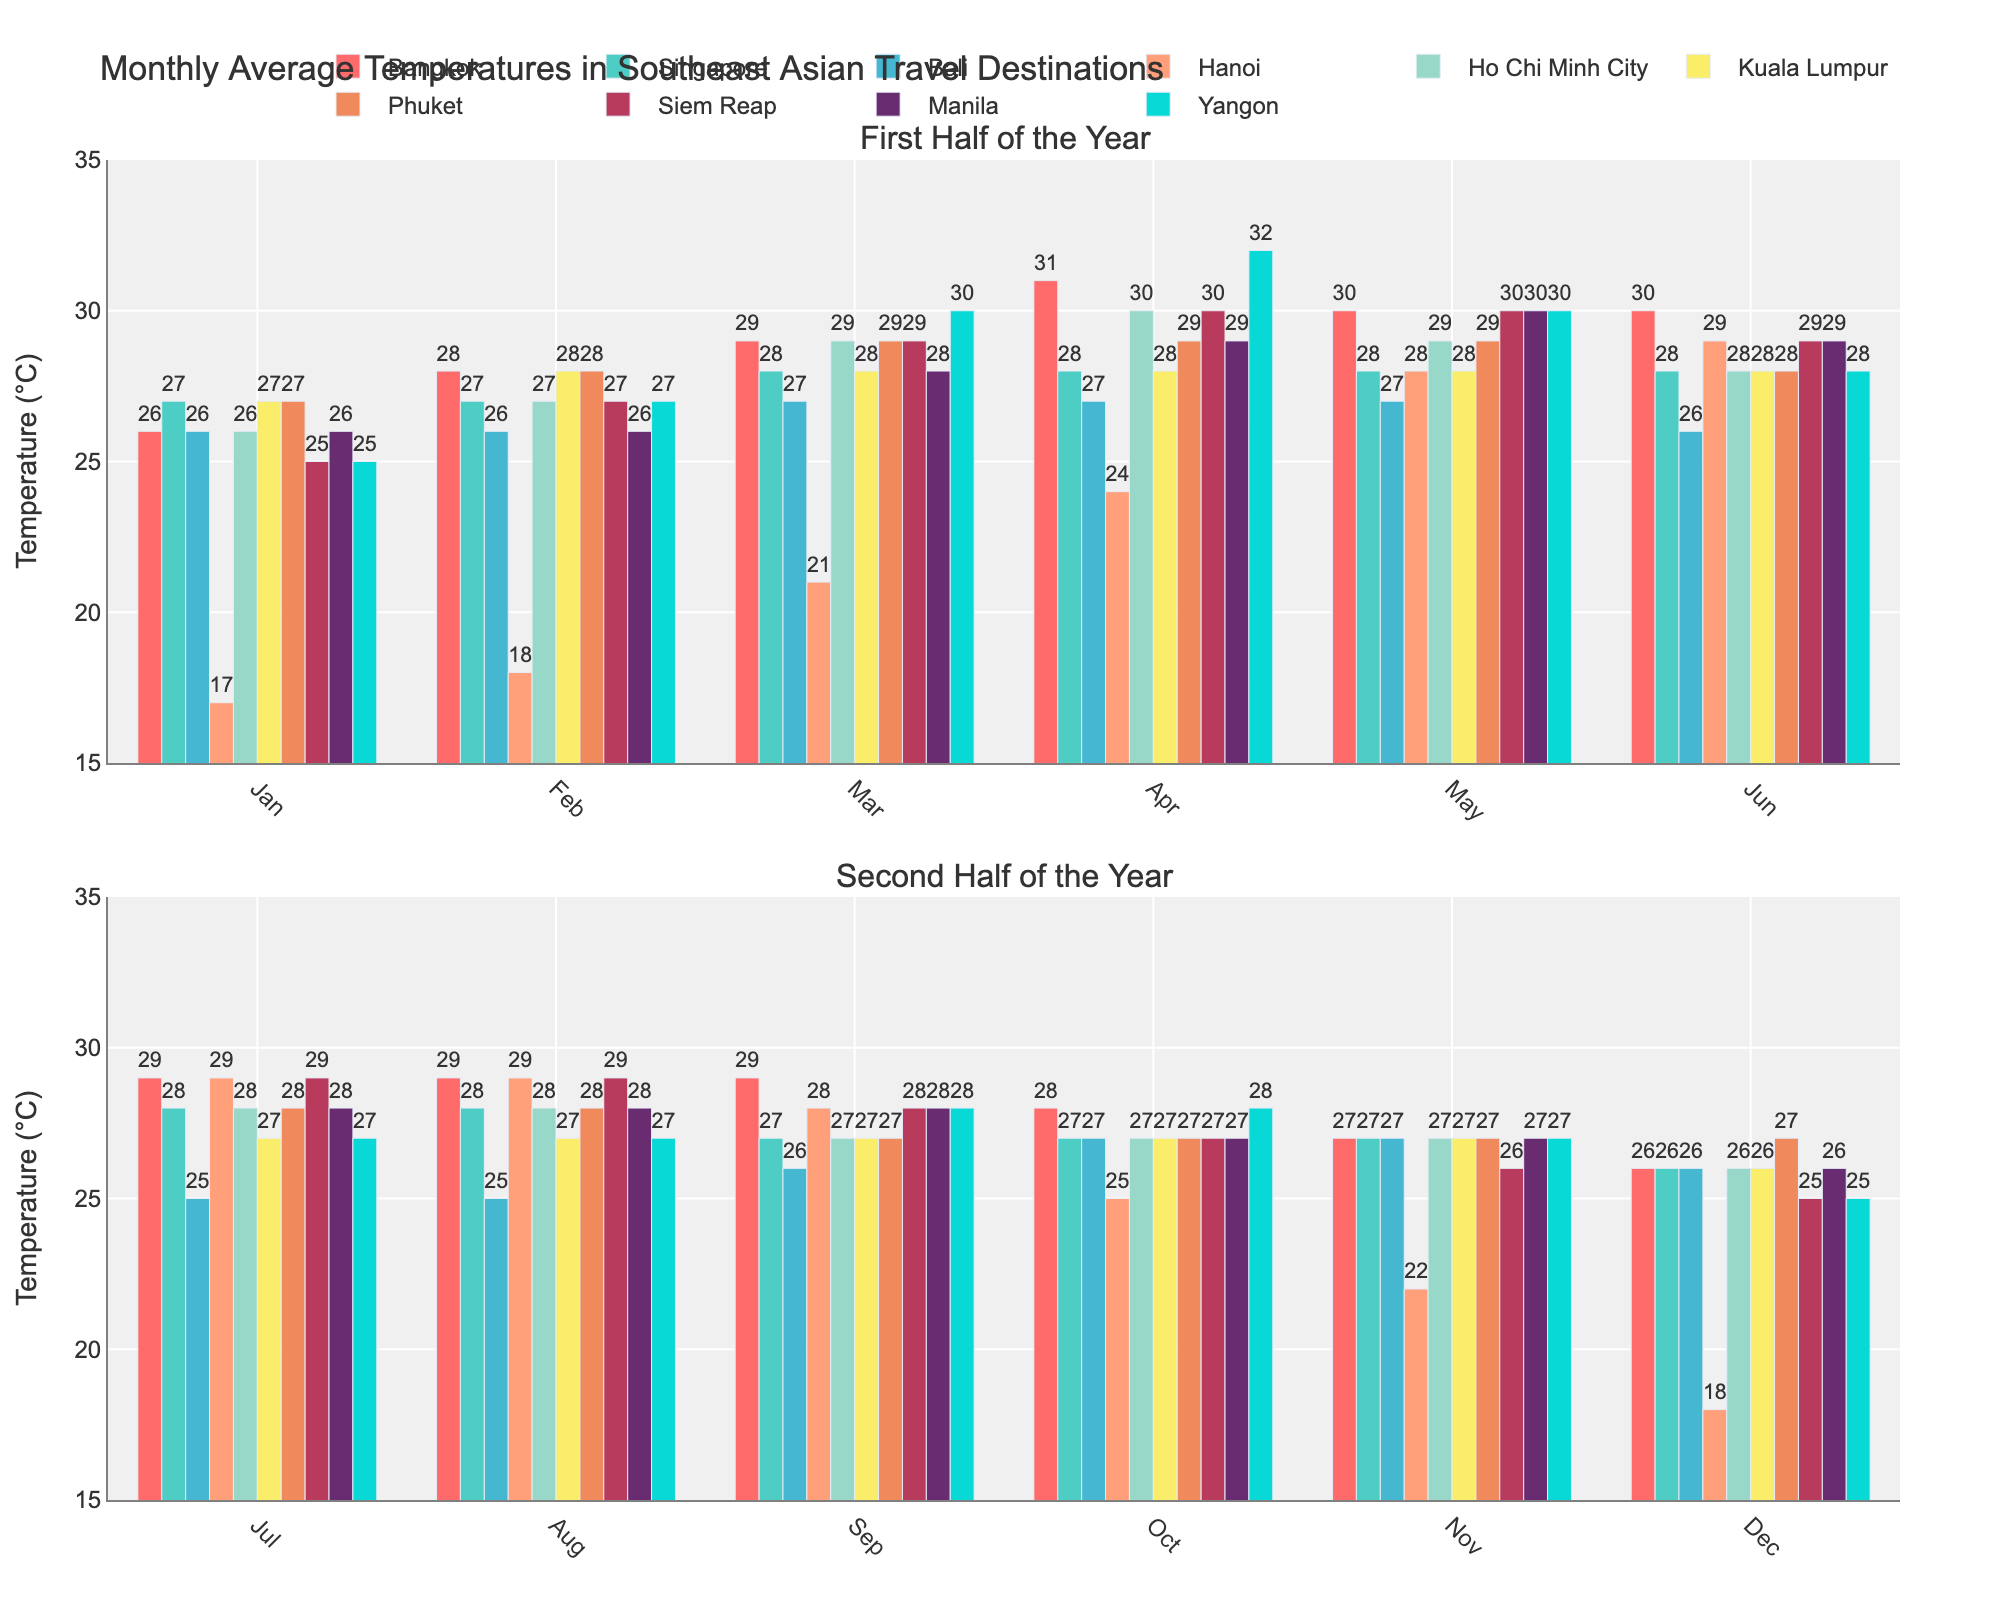What's the average temperature in Bangkok for the entire year? To find the average temperature in Bangkok, sum the monthly averages and divide by 12. The temperatures are 26, 28, 29, 31, 30, 30, 29, 29, 29, 28, 27, and 26. Sum them: 342. Divide by 12: 342 / 12 = 28.5
Answer: 28.5°C Which city has the highest average temperature in April? Looking at April, compare the temperatures of all cities. Bangkok has 31°C, Singapore 28°C, Bali 27°C, Hanoi 24°C, Ho Chi Minh City 30°C, Kuala Lumpur 28°C, Phuket 29°C, Siem Reap 30°C, Manila 29°C, Yangon 32°C. Yangon has the highest temperature at 32°C.
Answer: Yangon Which month has the lowest average temperature in Hanoi? Observe Hanoi's temperature for each month and identify the lowest value. The temperatures are: Jan 17°C, Feb 18°C, Mar 21°C, Apr 24°C, May 28°C, Jun 29°C, Jul 29°C, Aug 29°C, Sep 28°C, Oct 25°C, Nov 22°C, Dec 18°C. The lowest temperature is 17°C in January.
Answer: January What's the difference in average temperature between January and July for Bali? To find the difference, subtract January's temperature from July's. In Bali, January is 26°C, and July is 25°C. The difference is 25 - 26 = -1°C.
Answer: -1°C Which city shows the smallest variation in temperature throughout the year? Calculate the range (difference between highest and lowest temperatures) for each city: 
Bangkok (31-26=5), 
Singapore (28-26=2), 
Bali (27-25=2), 
Hanoi (29-17=12), 
Ho Chi Minh City (30-26=4), 
Kuala Lumpur (28-26=2), 
Phuket (29-27=2), 
Siem Reap (30-25=5), 
Manila (30-26=4), 
Yangon (32-25=7). 
The smallest variation is 2°C (Singapore, Bali, Kuala Lumpur, or Phuket).
Answer: Singapore, Bali, Kuala Lumpur, or Phuket In which month does Yangon experience its highest temperature? Looking at Yangon's temperatures, identify the highest value throughout the year. The temperatures are: Jan 25°C, Feb 27°C, Mar 30°C, Apr 32°C, May 30°C, Jun 28°C, Jul 27°C, Aug 27°C, Sep 28°C, Oct 28°C, Nov 27°C, Dec 25°C. The highest temperature of 32°C occurs in April.
Answer: April Compare the average July temperatures of Ho Chi Minh City and Phuket. Which city is warmer? Ho Chi Minh City has 28°C in July, and Phuket also has 28°C in July. Both cities have the same average temperature.
Answer: Same What's the temperature range (difference between highest and lowest temperatures) in Siem Reap throughout the year? Subtract the lowest monthly average temperature from the highest. For Siem Reap, the temperatures are: Jan 25°C, Feb 27°C, Mar 29°C, Apr 30°C, May 30°C, Jun 29°C, Jul 29°C, Aug 29°C, Sep 28°C, Oct 27°C, Nov 26°C, Dec 25°C. The range is 30 - 25 = 5°C.
Answer: 5°C 